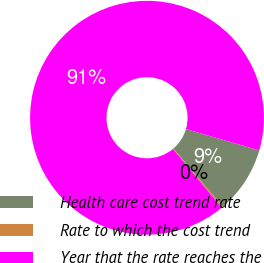Convert chart to OTSL. <chart><loc_0><loc_0><loc_500><loc_500><pie_chart><fcel>Health care cost trend rate<fcel>Rate to which the cost trend<fcel>Year that the rate reaches the<nl><fcel>9.25%<fcel>0.22%<fcel>90.52%<nl></chart> 